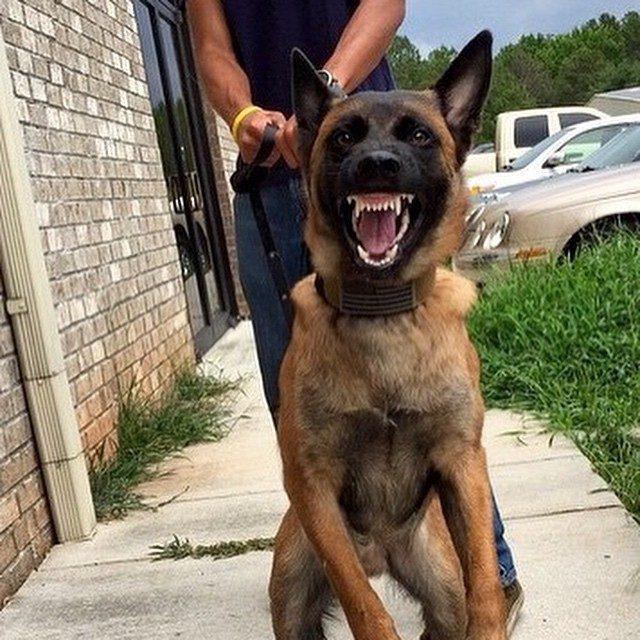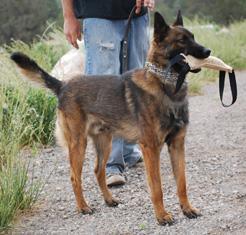The first image is the image on the left, the second image is the image on the right. Analyze the images presented: Is the assertion "the puppy is sitting on a wooden platform" valid? Answer yes or no. No. The first image is the image on the left, the second image is the image on the right. Assess this claim about the two images: "A dog is carrying something in its mouth". Correct or not? Answer yes or no. Yes. 